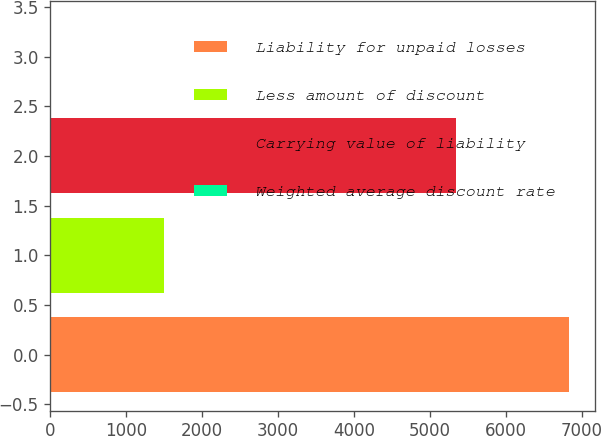Convert chart to OTSL. <chart><loc_0><loc_0><loc_500><loc_500><bar_chart><fcel>Liability for unpaid losses<fcel>Less amount of discount<fcel>Carrying value of liability<fcel>Weighted average discount rate<nl><fcel>6841<fcel>1502<fcel>5339<fcel>4.5<nl></chart> 